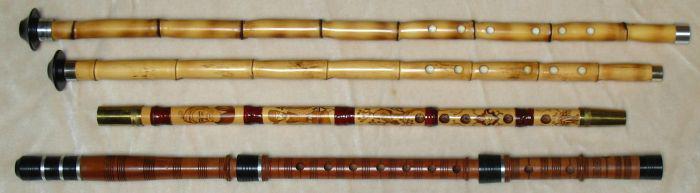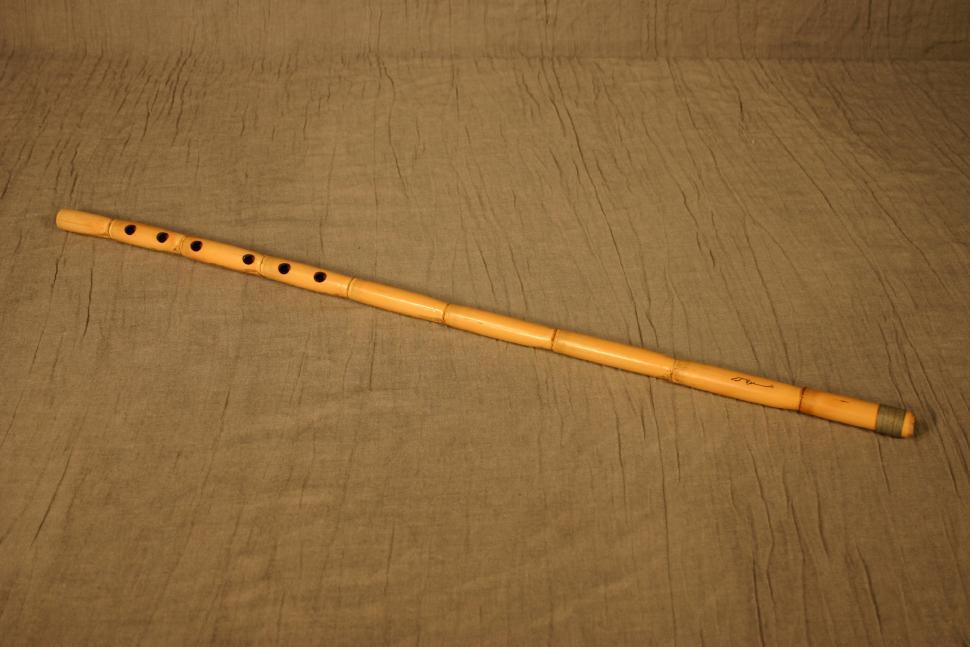The first image is the image on the left, the second image is the image on the right. For the images displayed, is the sentence "Each image contains one perforated, stick-like instrument displayed at an angle, and the right image shows an instrument with a leather tie on one end." factually correct? Answer yes or no. No. The first image is the image on the left, the second image is the image on the right. For the images displayed, is the sentence "there are two flutes in the image pair" factually correct? Answer yes or no. No. 